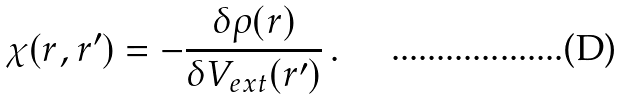<formula> <loc_0><loc_0><loc_500><loc_500>\chi ( { r } , { r } ^ { \prime } ) = - \frac { \delta \rho ( { r } ) } { \delta V _ { e x t } ( { r } ^ { \prime } ) } \, .</formula> 